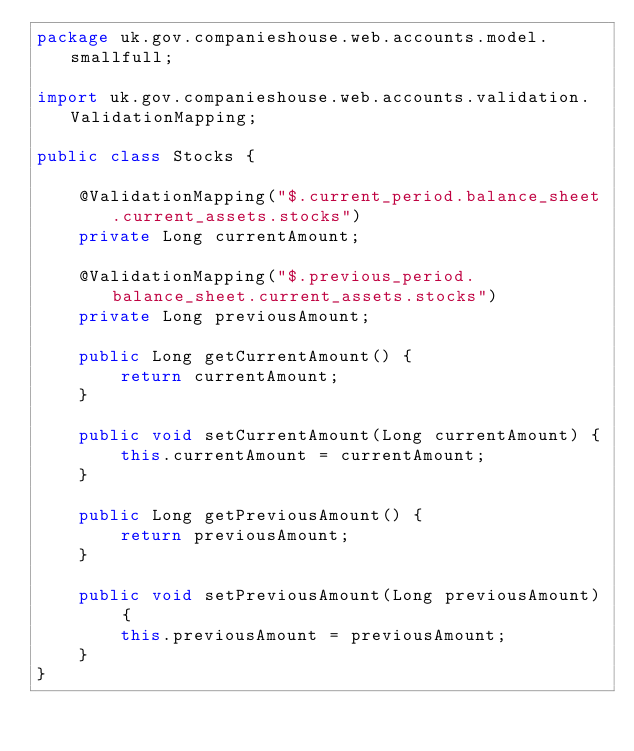Convert code to text. <code><loc_0><loc_0><loc_500><loc_500><_Java_>package uk.gov.companieshouse.web.accounts.model.smallfull;

import uk.gov.companieshouse.web.accounts.validation.ValidationMapping;

public class Stocks {

    @ValidationMapping("$.current_period.balance_sheet.current_assets.stocks")
    private Long currentAmount;

    @ValidationMapping("$.previous_period.balance_sheet.current_assets.stocks")
    private Long previousAmount;

    public Long getCurrentAmount() {
        return currentAmount;
    }

    public void setCurrentAmount(Long currentAmount) {
        this.currentAmount = currentAmount;
    }

    public Long getPreviousAmount() {
        return previousAmount;
    }

    public void setPreviousAmount(Long previousAmount) {
        this.previousAmount = previousAmount;
    }
}
</code> 